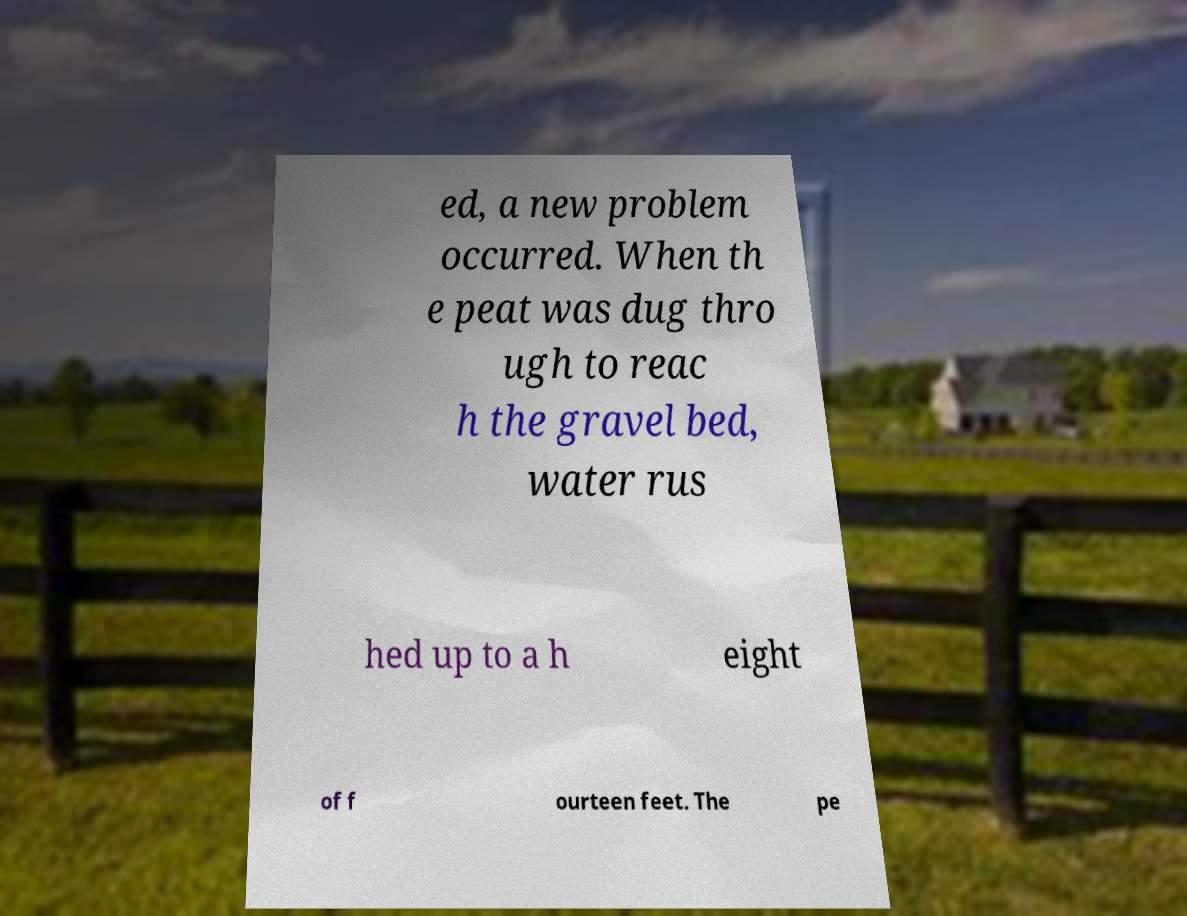There's text embedded in this image that I need extracted. Can you transcribe it verbatim? ed, a new problem occurred. When th e peat was dug thro ugh to reac h the gravel bed, water rus hed up to a h eight of f ourteen feet. The pe 